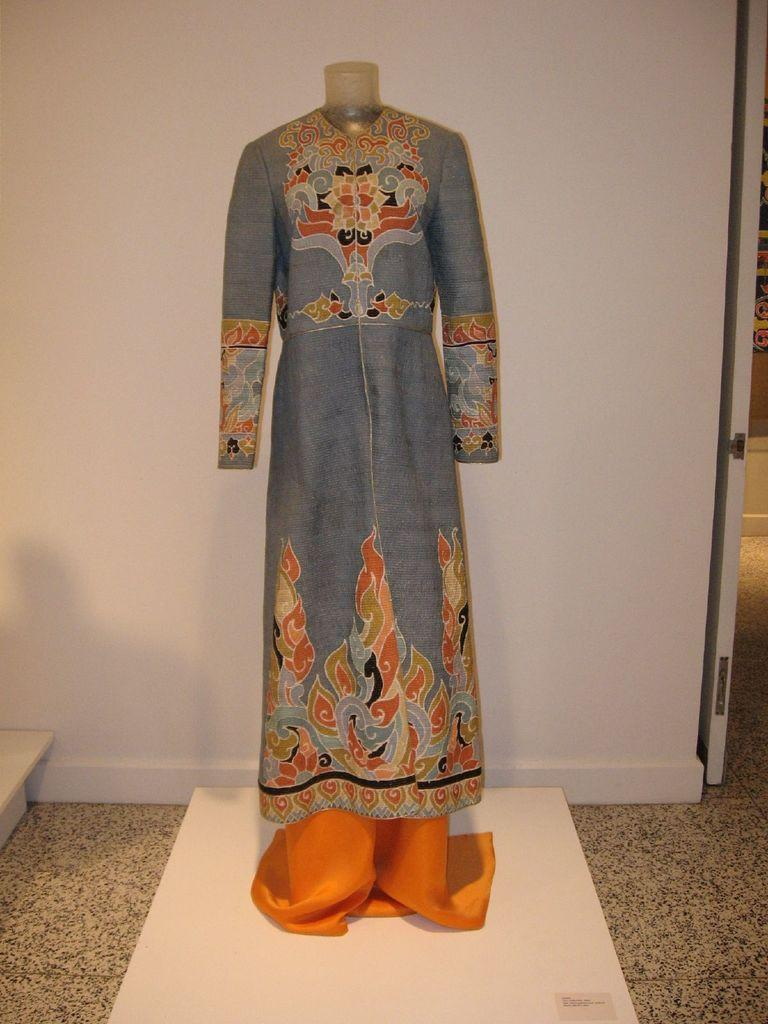What is the main subject of the image? There is a mannequin in the image. What is the mannequin wearing? The mannequin is wearing a dress. Where is the mannequin located? The mannequin is on a platform. What can be seen in the background of the image? There is a wall in the background of the image. How much money is the mannequin holding in the image? There is no money present in the image; the mannequin is wearing a dress and standing on a platform. 